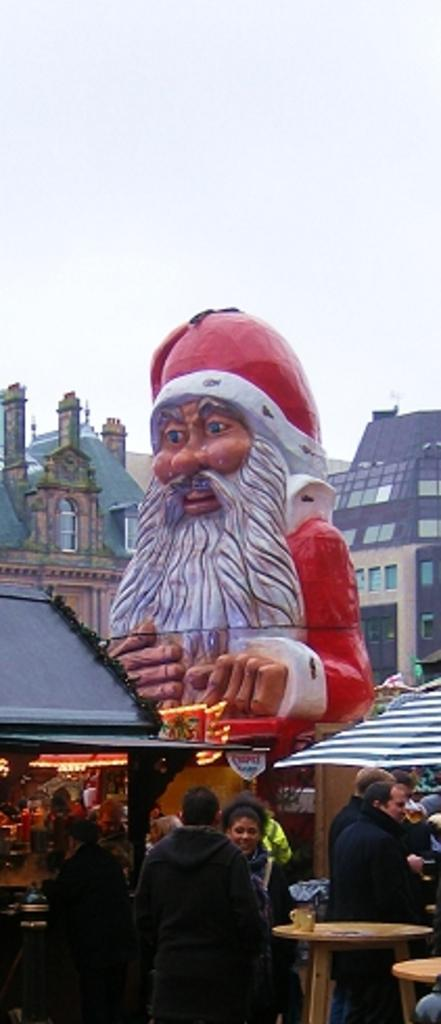What are the people in the image doing? The persons are standing in front of a table. What objects can be seen on the table? There are glasses on the table. What can be seen in the background of the image? There are buildings with windows and a toy-like statue in the background, as well as the sky. Who is the friend that is helping the person in the image? There is no friend present in the image; the persons are standing independently. What type of cover is being used to protect the toy-like statue in the image? There is no cover present in the image. 